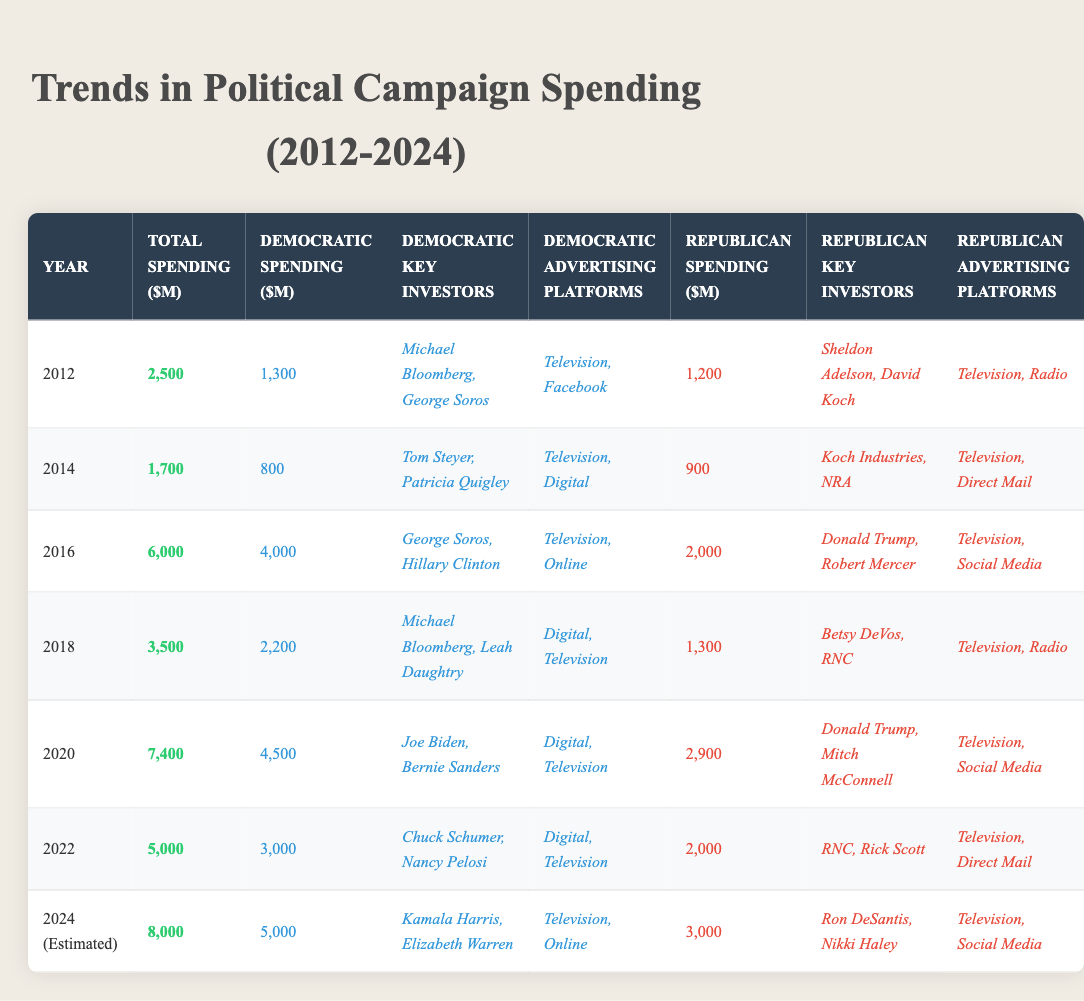What was the total spending in 2016? From the table, the total spending for the year 2016 is clearly listed as 6000 million dollars.
Answer: 6000 million dollars Which party spent more in 2020? In the table, 2020 shows that the Democratic Party spent 4500 million dollars, while the Republican Party spent 2900 million dollars. Thus, the Democratic Party spent more.
Answer: Democratic Party Who were the key investors for the Republican Party in 2018? The table lists the key investors for the Republican Party in 2018 as Betsy DeVos and RNC.
Answer: Betsy DeVos, RNC What was the difference in total spending between 2020 and 2022? The total spending in 2020 was 7400 million dollars, and in 2022 it was 5000 million dollars. The difference is calculated as 7400 - 5000 = 2400 million dollars.
Answer: 2400 million dollars Did the Republican Party's spending increase or decrease from 2016 to 2018? In 2016 the Republican Party spent 2000 million dollars, and in 2018 they spent 1300 million dollars. This shows a decrease since 2000 > 1300.
Answer: Decrease What is the average Democratic spending over the years listed? The total Democratic spending across the years is 1300 + 800 + 4000 + 2200 + 4500 + 3000 + 5000 = 20800 million dollars. There are 6 years total, so the average is 20800 / 6 = approximately 3466.67 million dollars.
Answer: Approximately 3466.67 million dollars Which advertising platform was used by both parties in 2016? The table shows that both parties used "Television" as an advertising platform in 2016, making it common to both.
Answer: Television Was the total spending in 2014 greater than in 2012? The total spending for 2014 is listed as 1700 million dollars, while for 2012 it is 2500 million dollars. Since 1700 < 2500, the statement is false.
Answer: No What was the total estimated spending for 2024? The table indicates that the estimated total spending for 2024 is 8000 million dollars.
Answer: 8000 million dollars If we compare the Democratic spending in 2016 and 2020, which year had more? The Democratic spending in 2016 was 4000 million dollars, while in 2020 it was 4500 million dollars. Since 4500 > 4000, 2020 had more spending.
Answer: 2020 had more spending 